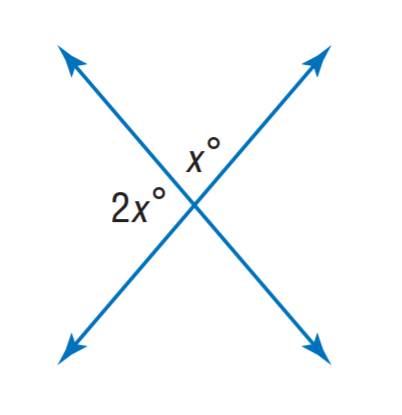Answer the mathemtical geometry problem and directly provide the correct option letter.
Question: Find x.
Choices: A: 40 B: 60 C: 80 D: 100 B 